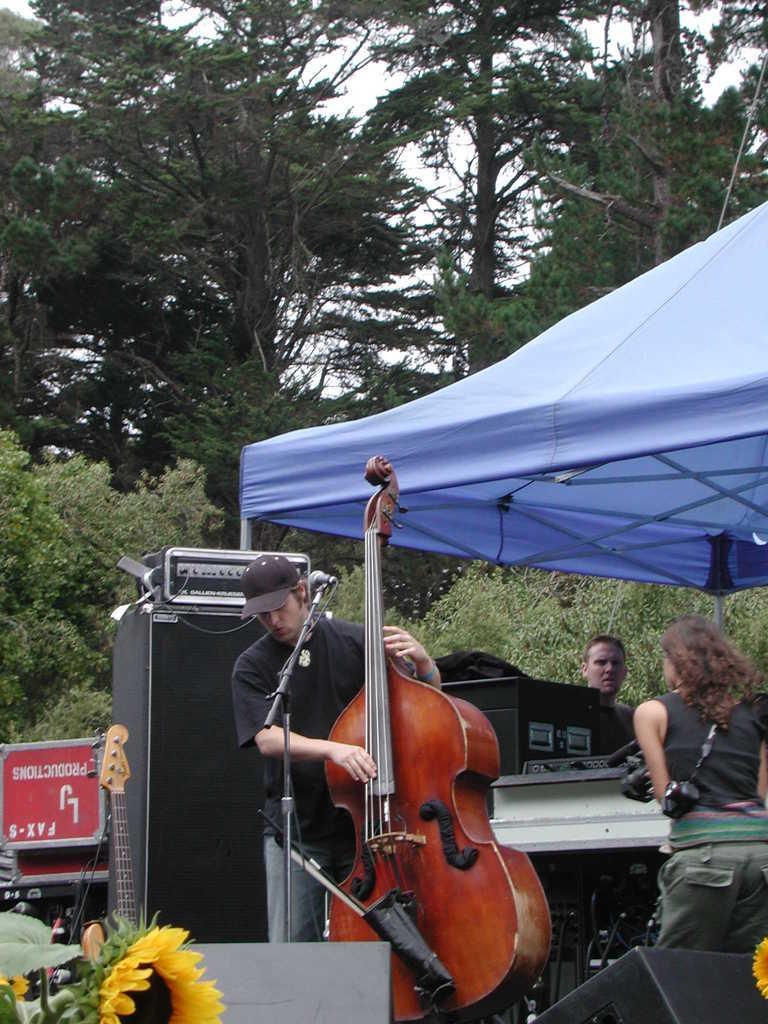Describe this image in one or two sentences. In this picture we can see three persons are standing, at the left bottom there is a flower, a man in the middle is playing a double bass, there is a microphone in front of him, it looks like a speaker on the left side, in the background there are some trees, we can see the sky at the top of the picture, we can see some boxes in the middle. 